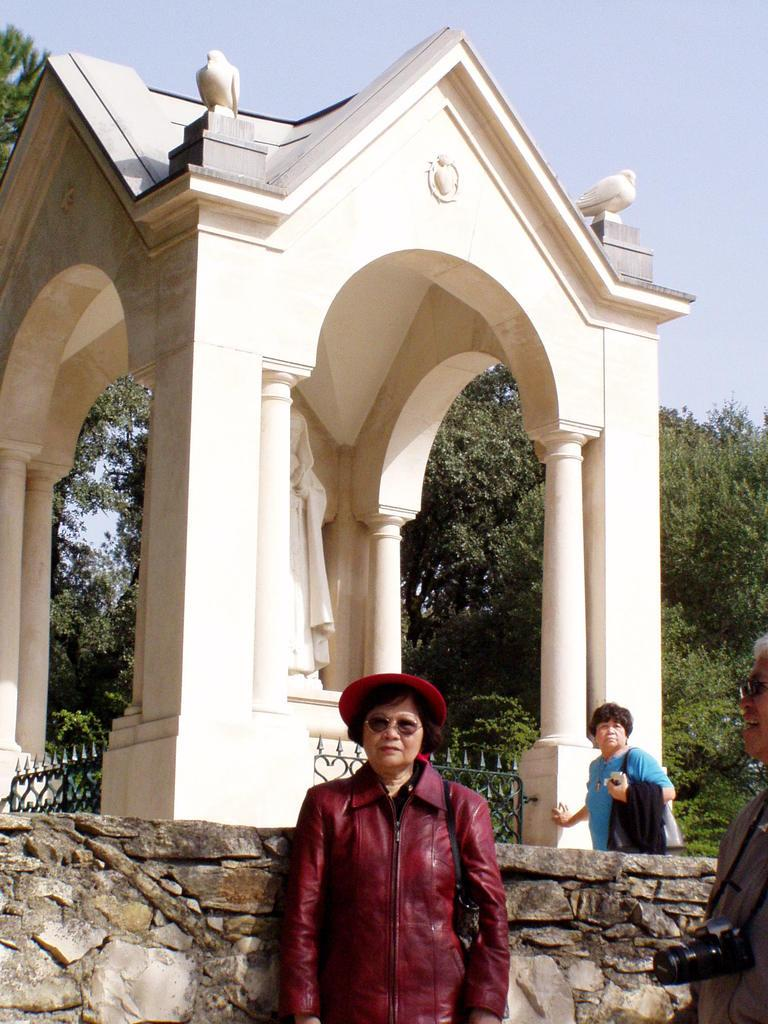How many people are in the image? There are three persons in the image. What structure can be seen in the image? There is a gazebo in the image. What is on the gazebo? The gazebo has a statue and iron grilles. What can be seen in the background of the image? There are trees and the sky visible in the background of the image. What type of mountain is visible in the image? There is no mountain visible in the image; it features a gazebo with a statue and iron grilles, surrounded by trees and the sky. What country is the gazebo located in, based on the image? The image does not provide any information about the country where the gazebo is located. 